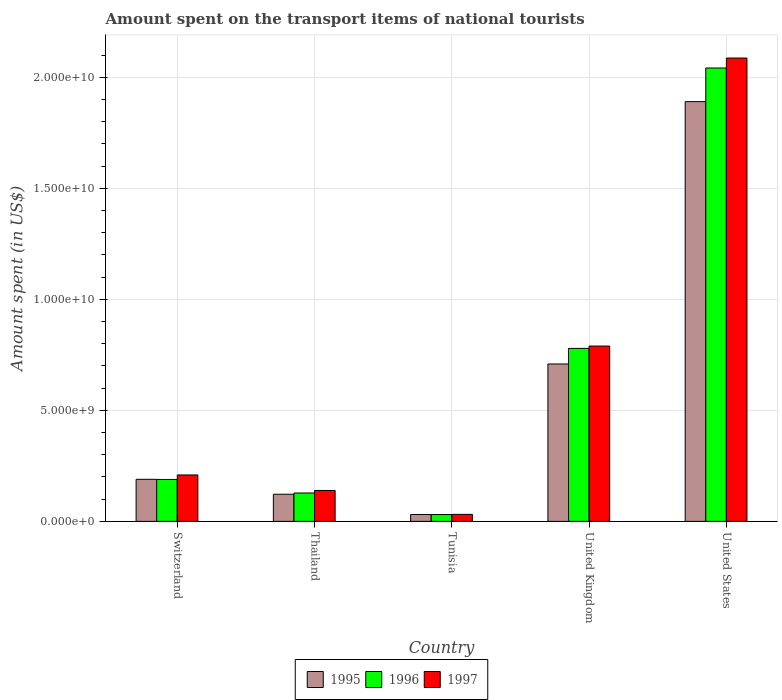How many groups of bars are there?
Your answer should be compact. 5. Are the number of bars per tick equal to the number of legend labels?
Your answer should be compact. Yes. How many bars are there on the 4th tick from the right?
Your answer should be compact. 3. What is the label of the 1st group of bars from the left?
Make the answer very short. Switzerland. What is the amount spent on the transport items of national tourists in 1996 in Tunisia?
Ensure brevity in your answer.  3.07e+08. Across all countries, what is the maximum amount spent on the transport items of national tourists in 1997?
Keep it short and to the point. 2.09e+1. Across all countries, what is the minimum amount spent on the transport items of national tourists in 1995?
Your response must be concise. 3.08e+08. In which country was the amount spent on the transport items of national tourists in 1996 minimum?
Offer a very short reply. Tunisia. What is the total amount spent on the transport items of national tourists in 1996 in the graph?
Your response must be concise. 3.17e+1. What is the difference between the amount spent on the transport items of national tourists in 1995 in Tunisia and that in United Kingdom?
Your answer should be compact. -6.78e+09. What is the difference between the amount spent on the transport items of national tourists in 1995 in Switzerland and the amount spent on the transport items of national tourists in 1996 in United States?
Make the answer very short. -1.85e+1. What is the average amount spent on the transport items of national tourists in 1995 per country?
Provide a short and direct response. 5.88e+09. What is the difference between the amount spent on the transport items of national tourists of/in 1996 and amount spent on the transport items of national tourists of/in 1995 in United States?
Ensure brevity in your answer.  1.52e+09. In how many countries, is the amount spent on the transport items of national tourists in 1996 greater than 7000000000 US$?
Your answer should be very brief. 2. What is the ratio of the amount spent on the transport items of national tourists in 1996 in Switzerland to that in Thailand?
Your answer should be very brief. 1.48. Is the amount spent on the transport items of national tourists in 1996 in Thailand less than that in Tunisia?
Your response must be concise. No. Is the difference between the amount spent on the transport items of national tourists in 1996 in United Kingdom and United States greater than the difference between the amount spent on the transport items of national tourists in 1995 in United Kingdom and United States?
Provide a short and direct response. No. What is the difference between the highest and the second highest amount spent on the transport items of national tourists in 1995?
Your answer should be compact. 1.18e+1. What is the difference between the highest and the lowest amount spent on the transport items of national tourists in 1997?
Your response must be concise. 2.06e+1. What does the 2nd bar from the left in Tunisia represents?
Ensure brevity in your answer.  1996. Are all the bars in the graph horizontal?
Make the answer very short. No. How many countries are there in the graph?
Offer a terse response. 5. Where does the legend appear in the graph?
Offer a very short reply. Bottom center. How many legend labels are there?
Keep it short and to the point. 3. What is the title of the graph?
Provide a succinct answer. Amount spent on the transport items of national tourists. Does "1964" appear as one of the legend labels in the graph?
Provide a succinct answer. No. What is the label or title of the Y-axis?
Your answer should be compact. Amount spent (in US$). What is the Amount spent (in US$) of 1995 in Switzerland?
Keep it short and to the point. 1.90e+09. What is the Amount spent (in US$) in 1996 in Switzerland?
Make the answer very short. 1.89e+09. What is the Amount spent (in US$) in 1997 in Switzerland?
Offer a terse response. 2.09e+09. What is the Amount spent (in US$) of 1995 in Thailand?
Your answer should be very brief. 1.22e+09. What is the Amount spent (in US$) in 1996 in Thailand?
Provide a short and direct response. 1.28e+09. What is the Amount spent (in US$) of 1997 in Thailand?
Provide a short and direct response. 1.39e+09. What is the Amount spent (in US$) in 1995 in Tunisia?
Make the answer very short. 3.08e+08. What is the Amount spent (in US$) in 1996 in Tunisia?
Ensure brevity in your answer.  3.07e+08. What is the Amount spent (in US$) of 1997 in Tunisia?
Offer a very short reply. 3.15e+08. What is the Amount spent (in US$) of 1995 in United Kingdom?
Offer a terse response. 7.09e+09. What is the Amount spent (in US$) in 1996 in United Kingdom?
Keep it short and to the point. 7.79e+09. What is the Amount spent (in US$) of 1997 in United Kingdom?
Keep it short and to the point. 7.90e+09. What is the Amount spent (in US$) of 1995 in United States?
Your response must be concise. 1.89e+1. What is the Amount spent (in US$) in 1996 in United States?
Provide a short and direct response. 2.04e+1. What is the Amount spent (in US$) of 1997 in United States?
Provide a short and direct response. 2.09e+1. Across all countries, what is the maximum Amount spent (in US$) of 1995?
Offer a very short reply. 1.89e+1. Across all countries, what is the maximum Amount spent (in US$) in 1996?
Offer a terse response. 2.04e+1. Across all countries, what is the maximum Amount spent (in US$) of 1997?
Provide a succinct answer. 2.09e+1. Across all countries, what is the minimum Amount spent (in US$) of 1995?
Provide a short and direct response. 3.08e+08. Across all countries, what is the minimum Amount spent (in US$) in 1996?
Provide a short and direct response. 3.07e+08. Across all countries, what is the minimum Amount spent (in US$) of 1997?
Your response must be concise. 3.15e+08. What is the total Amount spent (in US$) in 1995 in the graph?
Offer a very short reply. 2.94e+1. What is the total Amount spent (in US$) of 1996 in the graph?
Give a very brief answer. 3.17e+1. What is the total Amount spent (in US$) in 1997 in the graph?
Give a very brief answer. 3.26e+1. What is the difference between the Amount spent (in US$) in 1995 in Switzerland and that in Thailand?
Offer a very short reply. 6.73e+08. What is the difference between the Amount spent (in US$) in 1996 in Switzerland and that in Thailand?
Your response must be concise. 6.10e+08. What is the difference between the Amount spent (in US$) of 1997 in Switzerland and that in Thailand?
Keep it short and to the point. 6.99e+08. What is the difference between the Amount spent (in US$) in 1995 in Switzerland and that in Tunisia?
Offer a terse response. 1.59e+09. What is the difference between the Amount spent (in US$) in 1996 in Switzerland and that in Tunisia?
Give a very brief answer. 1.58e+09. What is the difference between the Amount spent (in US$) in 1997 in Switzerland and that in Tunisia?
Give a very brief answer. 1.78e+09. What is the difference between the Amount spent (in US$) in 1995 in Switzerland and that in United Kingdom?
Your answer should be very brief. -5.20e+09. What is the difference between the Amount spent (in US$) of 1996 in Switzerland and that in United Kingdom?
Give a very brief answer. -5.90e+09. What is the difference between the Amount spent (in US$) in 1997 in Switzerland and that in United Kingdom?
Your response must be concise. -5.81e+09. What is the difference between the Amount spent (in US$) in 1995 in Switzerland and that in United States?
Offer a very short reply. -1.70e+1. What is the difference between the Amount spent (in US$) of 1996 in Switzerland and that in United States?
Offer a terse response. -1.85e+1. What is the difference between the Amount spent (in US$) in 1997 in Switzerland and that in United States?
Your answer should be compact. -1.88e+1. What is the difference between the Amount spent (in US$) of 1995 in Thailand and that in Tunisia?
Your response must be concise. 9.14e+08. What is the difference between the Amount spent (in US$) of 1996 in Thailand and that in Tunisia?
Make the answer very short. 9.71e+08. What is the difference between the Amount spent (in US$) in 1997 in Thailand and that in Tunisia?
Provide a short and direct response. 1.08e+09. What is the difference between the Amount spent (in US$) of 1995 in Thailand and that in United Kingdom?
Keep it short and to the point. -5.87e+09. What is the difference between the Amount spent (in US$) in 1996 in Thailand and that in United Kingdom?
Your response must be concise. -6.51e+09. What is the difference between the Amount spent (in US$) of 1997 in Thailand and that in United Kingdom?
Keep it short and to the point. -6.50e+09. What is the difference between the Amount spent (in US$) of 1995 in Thailand and that in United States?
Offer a very short reply. -1.77e+1. What is the difference between the Amount spent (in US$) in 1996 in Thailand and that in United States?
Give a very brief answer. -1.91e+1. What is the difference between the Amount spent (in US$) in 1997 in Thailand and that in United States?
Ensure brevity in your answer.  -1.95e+1. What is the difference between the Amount spent (in US$) in 1995 in Tunisia and that in United Kingdom?
Ensure brevity in your answer.  -6.78e+09. What is the difference between the Amount spent (in US$) in 1996 in Tunisia and that in United Kingdom?
Make the answer very short. -7.48e+09. What is the difference between the Amount spent (in US$) of 1997 in Tunisia and that in United Kingdom?
Make the answer very short. -7.58e+09. What is the difference between the Amount spent (in US$) in 1995 in Tunisia and that in United States?
Your answer should be very brief. -1.86e+1. What is the difference between the Amount spent (in US$) in 1996 in Tunisia and that in United States?
Your response must be concise. -2.01e+1. What is the difference between the Amount spent (in US$) in 1997 in Tunisia and that in United States?
Give a very brief answer. -2.06e+1. What is the difference between the Amount spent (in US$) in 1995 in United Kingdom and that in United States?
Give a very brief answer. -1.18e+1. What is the difference between the Amount spent (in US$) of 1996 in United Kingdom and that in United States?
Offer a terse response. -1.26e+1. What is the difference between the Amount spent (in US$) of 1997 in United Kingdom and that in United States?
Ensure brevity in your answer.  -1.30e+1. What is the difference between the Amount spent (in US$) in 1995 in Switzerland and the Amount spent (in US$) in 1996 in Thailand?
Your response must be concise. 6.17e+08. What is the difference between the Amount spent (in US$) in 1995 in Switzerland and the Amount spent (in US$) in 1997 in Thailand?
Offer a terse response. 5.03e+08. What is the difference between the Amount spent (in US$) in 1996 in Switzerland and the Amount spent (in US$) in 1997 in Thailand?
Offer a terse response. 4.96e+08. What is the difference between the Amount spent (in US$) of 1995 in Switzerland and the Amount spent (in US$) of 1996 in Tunisia?
Give a very brief answer. 1.59e+09. What is the difference between the Amount spent (in US$) in 1995 in Switzerland and the Amount spent (in US$) in 1997 in Tunisia?
Your answer should be compact. 1.58e+09. What is the difference between the Amount spent (in US$) of 1996 in Switzerland and the Amount spent (in US$) of 1997 in Tunisia?
Your answer should be compact. 1.57e+09. What is the difference between the Amount spent (in US$) in 1995 in Switzerland and the Amount spent (in US$) in 1996 in United Kingdom?
Offer a very short reply. -5.90e+09. What is the difference between the Amount spent (in US$) in 1995 in Switzerland and the Amount spent (in US$) in 1997 in United Kingdom?
Make the answer very short. -6.00e+09. What is the difference between the Amount spent (in US$) in 1996 in Switzerland and the Amount spent (in US$) in 1997 in United Kingdom?
Keep it short and to the point. -6.01e+09. What is the difference between the Amount spent (in US$) of 1995 in Switzerland and the Amount spent (in US$) of 1996 in United States?
Provide a succinct answer. -1.85e+1. What is the difference between the Amount spent (in US$) in 1995 in Switzerland and the Amount spent (in US$) in 1997 in United States?
Offer a very short reply. -1.90e+1. What is the difference between the Amount spent (in US$) of 1996 in Switzerland and the Amount spent (in US$) of 1997 in United States?
Ensure brevity in your answer.  -1.90e+1. What is the difference between the Amount spent (in US$) in 1995 in Thailand and the Amount spent (in US$) in 1996 in Tunisia?
Your answer should be compact. 9.15e+08. What is the difference between the Amount spent (in US$) in 1995 in Thailand and the Amount spent (in US$) in 1997 in Tunisia?
Provide a succinct answer. 9.07e+08. What is the difference between the Amount spent (in US$) of 1996 in Thailand and the Amount spent (in US$) of 1997 in Tunisia?
Ensure brevity in your answer.  9.63e+08. What is the difference between the Amount spent (in US$) in 1995 in Thailand and the Amount spent (in US$) in 1996 in United Kingdom?
Keep it short and to the point. -6.57e+09. What is the difference between the Amount spent (in US$) of 1995 in Thailand and the Amount spent (in US$) of 1997 in United Kingdom?
Offer a terse response. -6.68e+09. What is the difference between the Amount spent (in US$) of 1996 in Thailand and the Amount spent (in US$) of 1997 in United Kingdom?
Provide a short and direct response. -6.62e+09. What is the difference between the Amount spent (in US$) of 1995 in Thailand and the Amount spent (in US$) of 1996 in United States?
Ensure brevity in your answer.  -1.92e+1. What is the difference between the Amount spent (in US$) of 1995 in Thailand and the Amount spent (in US$) of 1997 in United States?
Provide a succinct answer. -1.96e+1. What is the difference between the Amount spent (in US$) in 1996 in Thailand and the Amount spent (in US$) in 1997 in United States?
Make the answer very short. -1.96e+1. What is the difference between the Amount spent (in US$) of 1995 in Tunisia and the Amount spent (in US$) of 1996 in United Kingdom?
Provide a short and direct response. -7.48e+09. What is the difference between the Amount spent (in US$) of 1995 in Tunisia and the Amount spent (in US$) of 1997 in United Kingdom?
Make the answer very short. -7.59e+09. What is the difference between the Amount spent (in US$) of 1996 in Tunisia and the Amount spent (in US$) of 1997 in United Kingdom?
Keep it short and to the point. -7.59e+09. What is the difference between the Amount spent (in US$) of 1995 in Tunisia and the Amount spent (in US$) of 1996 in United States?
Make the answer very short. -2.01e+1. What is the difference between the Amount spent (in US$) of 1995 in Tunisia and the Amount spent (in US$) of 1997 in United States?
Your answer should be compact. -2.06e+1. What is the difference between the Amount spent (in US$) in 1996 in Tunisia and the Amount spent (in US$) in 1997 in United States?
Your response must be concise. -2.06e+1. What is the difference between the Amount spent (in US$) in 1995 in United Kingdom and the Amount spent (in US$) in 1996 in United States?
Provide a succinct answer. -1.33e+1. What is the difference between the Amount spent (in US$) of 1995 in United Kingdom and the Amount spent (in US$) of 1997 in United States?
Keep it short and to the point. -1.38e+1. What is the difference between the Amount spent (in US$) of 1996 in United Kingdom and the Amount spent (in US$) of 1997 in United States?
Make the answer very short. -1.31e+1. What is the average Amount spent (in US$) in 1995 per country?
Provide a succinct answer. 5.88e+09. What is the average Amount spent (in US$) in 1996 per country?
Offer a very short reply. 6.34e+09. What is the average Amount spent (in US$) in 1997 per country?
Your answer should be very brief. 6.51e+09. What is the difference between the Amount spent (in US$) of 1995 and Amount spent (in US$) of 1996 in Switzerland?
Your response must be concise. 7.00e+06. What is the difference between the Amount spent (in US$) of 1995 and Amount spent (in US$) of 1997 in Switzerland?
Your response must be concise. -1.96e+08. What is the difference between the Amount spent (in US$) of 1996 and Amount spent (in US$) of 1997 in Switzerland?
Make the answer very short. -2.03e+08. What is the difference between the Amount spent (in US$) in 1995 and Amount spent (in US$) in 1996 in Thailand?
Your answer should be compact. -5.60e+07. What is the difference between the Amount spent (in US$) of 1995 and Amount spent (in US$) of 1997 in Thailand?
Provide a succinct answer. -1.70e+08. What is the difference between the Amount spent (in US$) of 1996 and Amount spent (in US$) of 1997 in Thailand?
Provide a succinct answer. -1.14e+08. What is the difference between the Amount spent (in US$) of 1995 and Amount spent (in US$) of 1996 in Tunisia?
Your answer should be compact. 1.00e+06. What is the difference between the Amount spent (in US$) of 1995 and Amount spent (in US$) of 1997 in Tunisia?
Offer a terse response. -7.00e+06. What is the difference between the Amount spent (in US$) in 1996 and Amount spent (in US$) in 1997 in Tunisia?
Provide a succinct answer. -8.00e+06. What is the difference between the Amount spent (in US$) in 1995 and Amount spent (in US$) in 1996 in United Kingdom?
Give a very brief answer. -7.02e+08. What is the difference between the Amount spent (in US$) of 1995 and Amount spent (in US$) of 1997 in United Kingdom?
Ensure brevity in your answer.  -8.07e+08. What is the difference between the Amount spent (in US$) in 1996 and Amount spent (in US$) in 1997 in United Kingdom?
Give a very brief answer. -1.05e+08. What is the difference between the Amount spent (in US$) of 1995 and Amount spent (in US$) of 1996 in United States?
Offer a very short reply. -1.52e+09. What is the difference between the Amount spent (in US$) of 1995 and Amount spent (in US$) of 1997 in United States?
Offer a terse response. -1.96e+09. What is the difference between the Amount spent (in US$) in 1996 and Amount spent (in US$) in 1997 in United States?
Your response must be concise. -4.48e+08. What is the ratio of the Amount spent (in US$) in 1995 in Switzerland to that in Thailand?
Keep it short and to the point. 1.55. What is the ratio of the Amount spent (in US$) of 1996 in Switzerland to that in Thailand?
Keep it short and to the point. 1.48. What is the ratio of the Amount spent (in US$) of 1997 in Switzerland to that in Thailand?
Your answer should be very brief. 1.5. What is the ratio of the Amount spent (in US$) in 1995 in Switzerland to that in Tunisia?
Offer a terse response. 6.15. What is the ratio of the Amount spent (in US$) of 1996 in Switzerland to that in Tunisia?
Your answer should be very brief. 6.15. What is the ratio of the Amount spent (in US$) of 1997 in Switzerland to that in Tunisia?
Ensure brevity in your answer.  6.64. What is the ratio of the Amount spent (in US$) in 1995 in Switzerland to that in United Kingdom?
Your answer should be very brief. 0.27. What is the ratio of the Amount spent (in US$) in 1996 in Switzerland to that in United Kingdom?
Make the answer very short. 0.24. What is the ratio of the Amount spent (in US$) in 1997 in Switzerland to that in United Kingdom?
Your answer should be compact. 0.26. What is the ratio of the Amount spent (in US$) in 1995 in Switzerland to that in United States?
Offer a very short reply. 0.1. What is the ratio of the Amount spent (in US$) of 1996 in Switzerland to that in United States?
Your response must be concise. 0.09. What is the ratio of the Amount spent (in US$) of 1997 in Switzerland to that in United States?
Your answer should be very brief. 0.1. What is the ratio of the Amount spent (in US$) in 1995 in Thailand to that in Tunisia?
Make the answer very short. 3.97. What is the ratio of the Amount spent (in US$) in 1996 in Thailand to that in Tunisia?
Your answer should be very brief. 4.16. What is the ratio of the Amount spent (in US$) in 1997 in Thailand to that in Tunisia?
Your response must be concise. 4.42. What is the ratio of the Amount spent (in US$) of 1995 in Thailand to that in United Kingdom?
Give a very brief answer. 0.17. What is the ratio of the Amount spent (in US$) in 1996 in Thailand to that in United Kingdom?
Provide a succinct answer. 0.16. What is the ratio of the Amount spent (in US$) in 1997 in Thailand to that in United Kingdom?
Your answer should be very brief. 0.18. What is the ratio of the Amount spent (in US$) in 1995 in Thailand to that in United States?
Provide a succinct answer. 0.06. What is the ratio of the Amount spent (in US$) of 1996 in Thailand to that in United States?
Provide a short and direct response. 0.06. What is the ratio of the Amount spent (in US$) in 1997 in Thailand to that in United States?
Provide a short and direct response. 0.07. What is the ratio of the Amount spent (in US$) of 1995 in Tunisia to that in United Kingdom?
Your answer should be very brief. 0.04. What is the ratio of the Amount spent (in US$) of 1996 in Tunisia to that in United Kingdom?
Ensure brevity in your answer.  0.04. What is the ratio of the Amount spent (in US$) in 1997 in Tunisia to that in United Kingdom?
Your response must be concise. 0.04. What is the ratio of the Amount spent (in US$) of 1995 in Tunisia to that in United States?
Your response must be concise. 0.02. What is the ratio of the Amount spent (in US$) in 1996 in Tunisia to that in United States?
Keep it short and to the point. 0.01. What is the ratio of the Amount spent (in US$) in 1997 in Tunisia to that in United States?
Make the answer very short. 0.02. What is the ratio of the Amount spent (in US$) in 1995 in United Kingdom to that in United States?
Give a very brief answer. 0.38. What is the ratio of the Amount spent (in US$) of 1996 in United Kingdom to that in United States?
Provide a short and direct response. 0.38. What is the ratio of the Amount spent (in US$) in 1997 in United Kingdom to that in United States?
Provide a short and direct response. 0.38. What is the difference between the highest and the second highest Amount spent (in US$) in 1995?
Your response must be concise. 1.18e+1. What is the difference between the highest and the second highest Amount spent (in US$) in 1996?
Your answer should be very brief. 1.26e+1. What is the difference between the highest and the second highest Amount spent (in US$) in 1997?
Your response must be concise. 1.30e+1. What is the difference between the highest and the lowest Amount spent (in US$) in 1995?
Offer a terse response. 1.86e+1. What is the difference between the highest and the lowest Amount spent (in US$) of 1996?
Offer a terse response. 2.01e+1. What is the difference between the highest and the lowest Amount spent (in US$) of 1997?
Provide a short and direct response. 2.06e+1. 